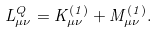<formula> <loc_0><loc_0><loc_500><loc_500>L ^ { Q } _ { \mu \nu } = K ^ { ( 1 ) } _ { \mu \nu } + M ^ { ( 1 ) } _ { \mu \nu } .</formula> 